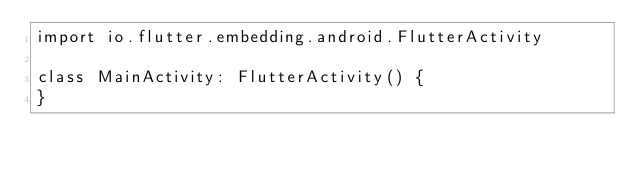Convert code to text. <code><loc_0><loc_0><loc_500><loc_500><_Kotlin_>import io.flutter.embedding.android.FlutterActivity

class MainActivity: FlutterActivity() {
}
</code> 